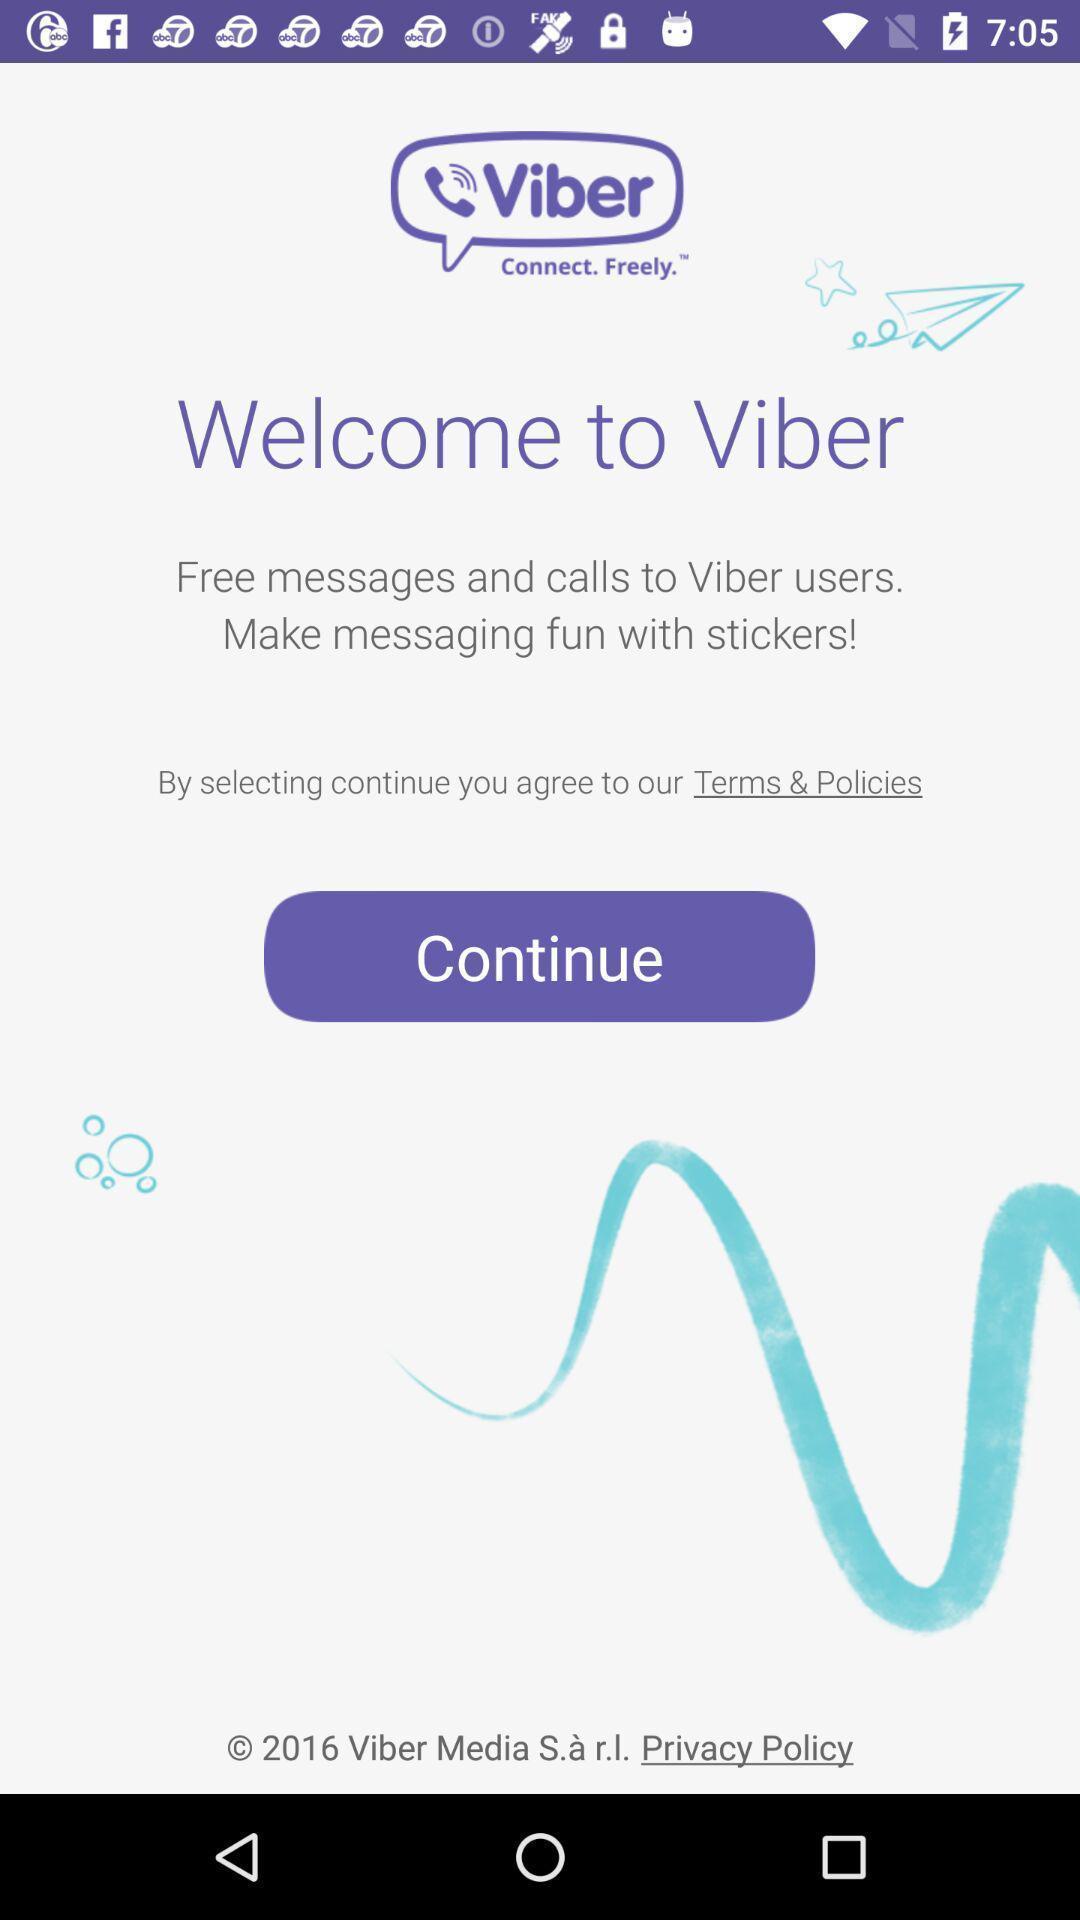Describe the content in this image. Welcome page. 